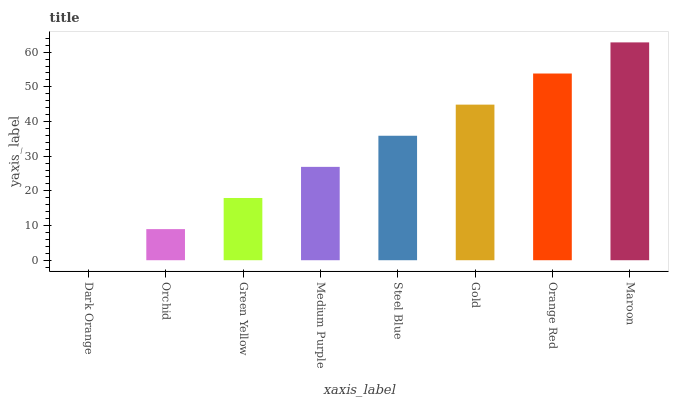Is Dark Orange the minimum?
Answer yes or no. Yes. Is Maroon the maximum?
Answer yes or no. Yes. Is Orchid the minimum?
Answer yes or no. No. Is Orchid the maximum?
Answer yes or no. No. Is Orchid greater than Dark Orange?
Answer yes or no. Yes. Is Dark Orange less than Orchid?
Answer yes or no. Yes. Is Dark Orange greater than Orchid?
Answer yes or no. No. Is Orchid less than Dark Orange?
Answer yes or no. No. Is Steel Blue the high median?
Answer yes or no. Yes. Is Medium Purple the low median?
Answer yes or no. Yes. Is Gold the high median?
Answer yes or no. No. Is Steel Blue the low median?
Answer yes or no. No. 